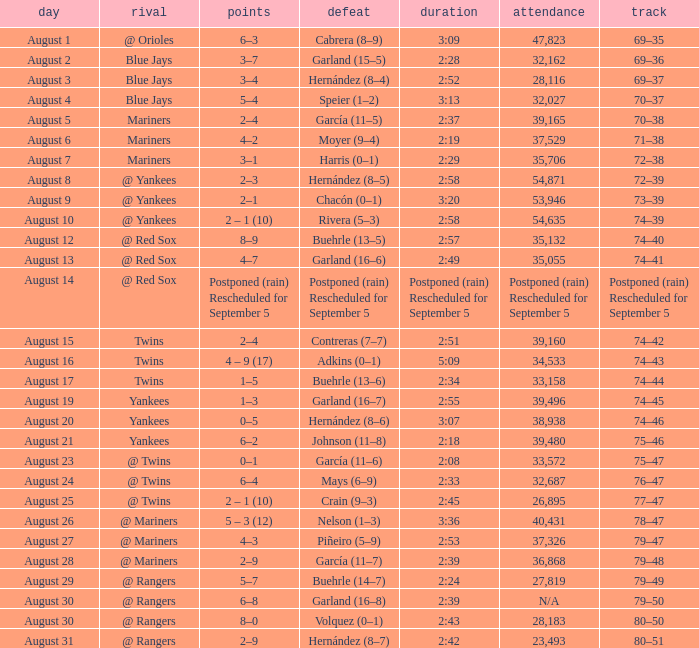Who lost on August 27? Piñeiro (5–9). 